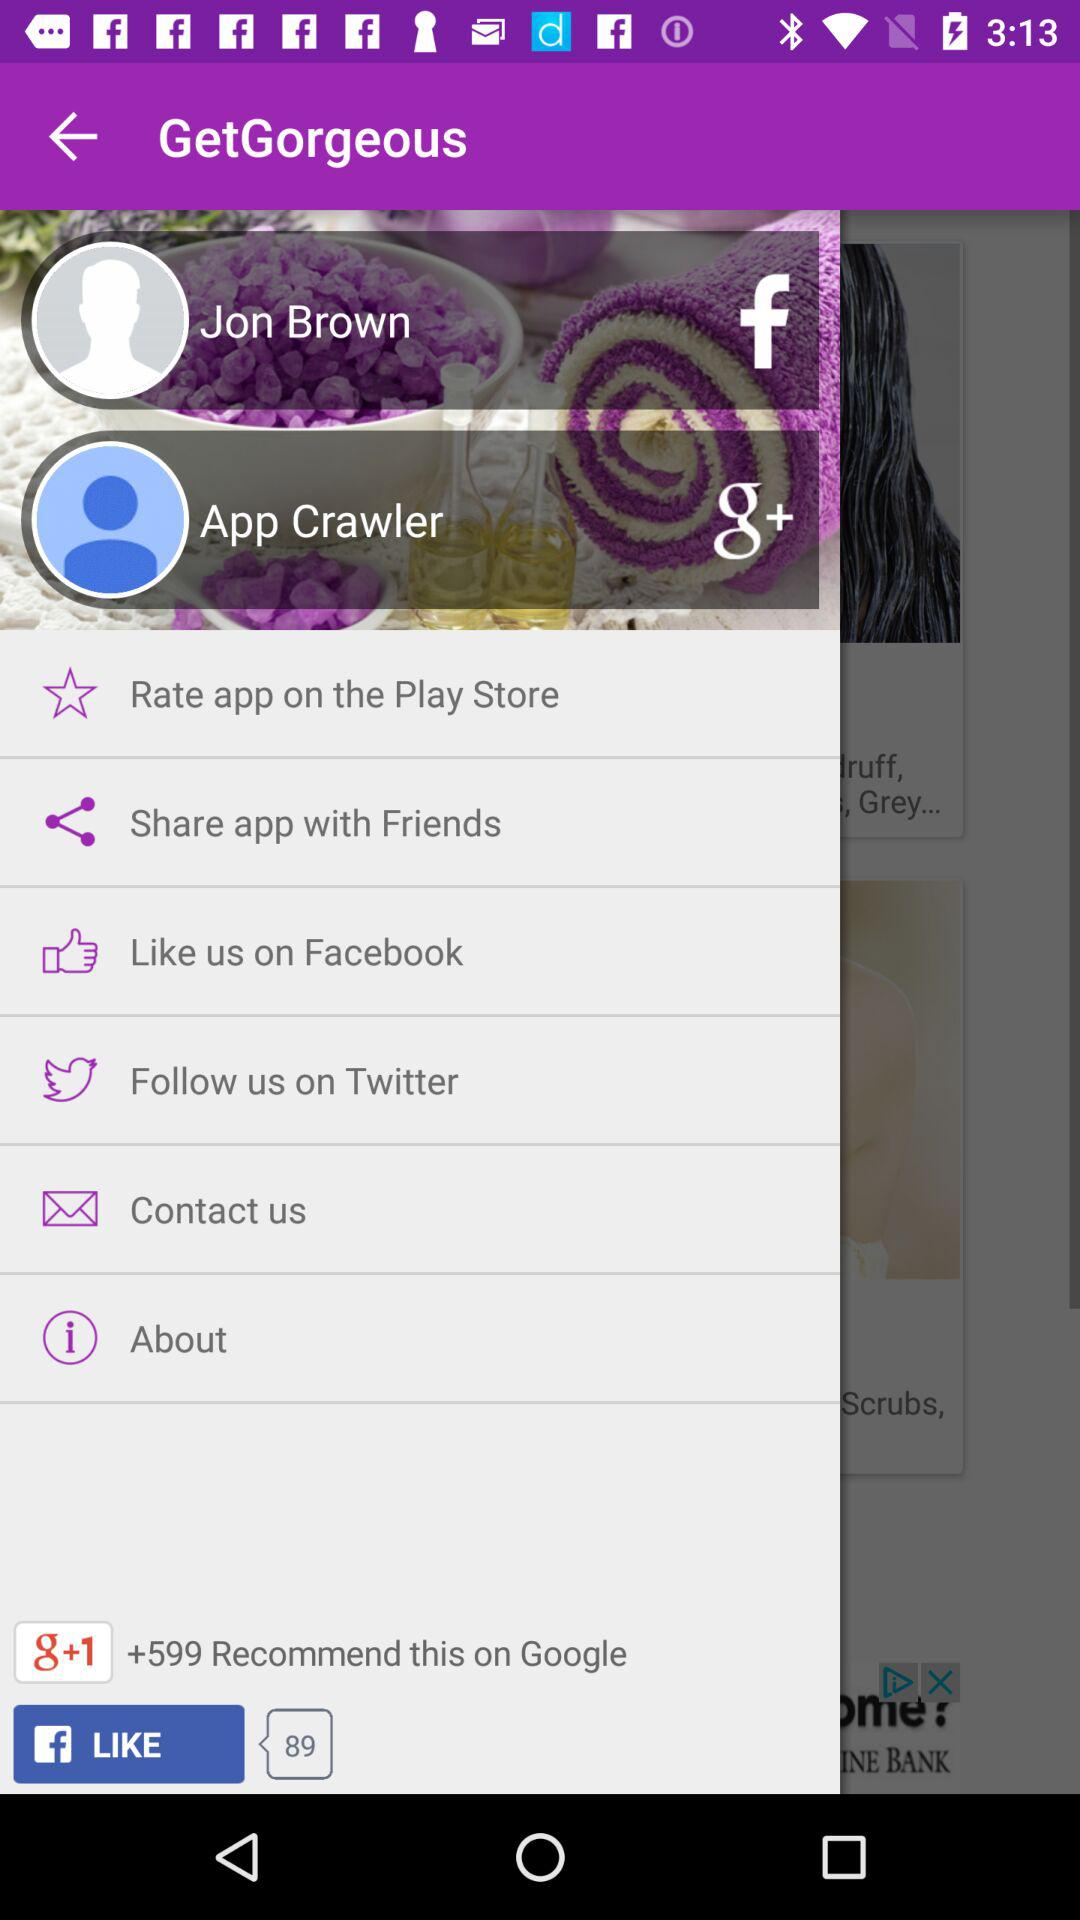What is the total number of comments on "Facebook"? The total number of comments on "Facebook" is 89. 